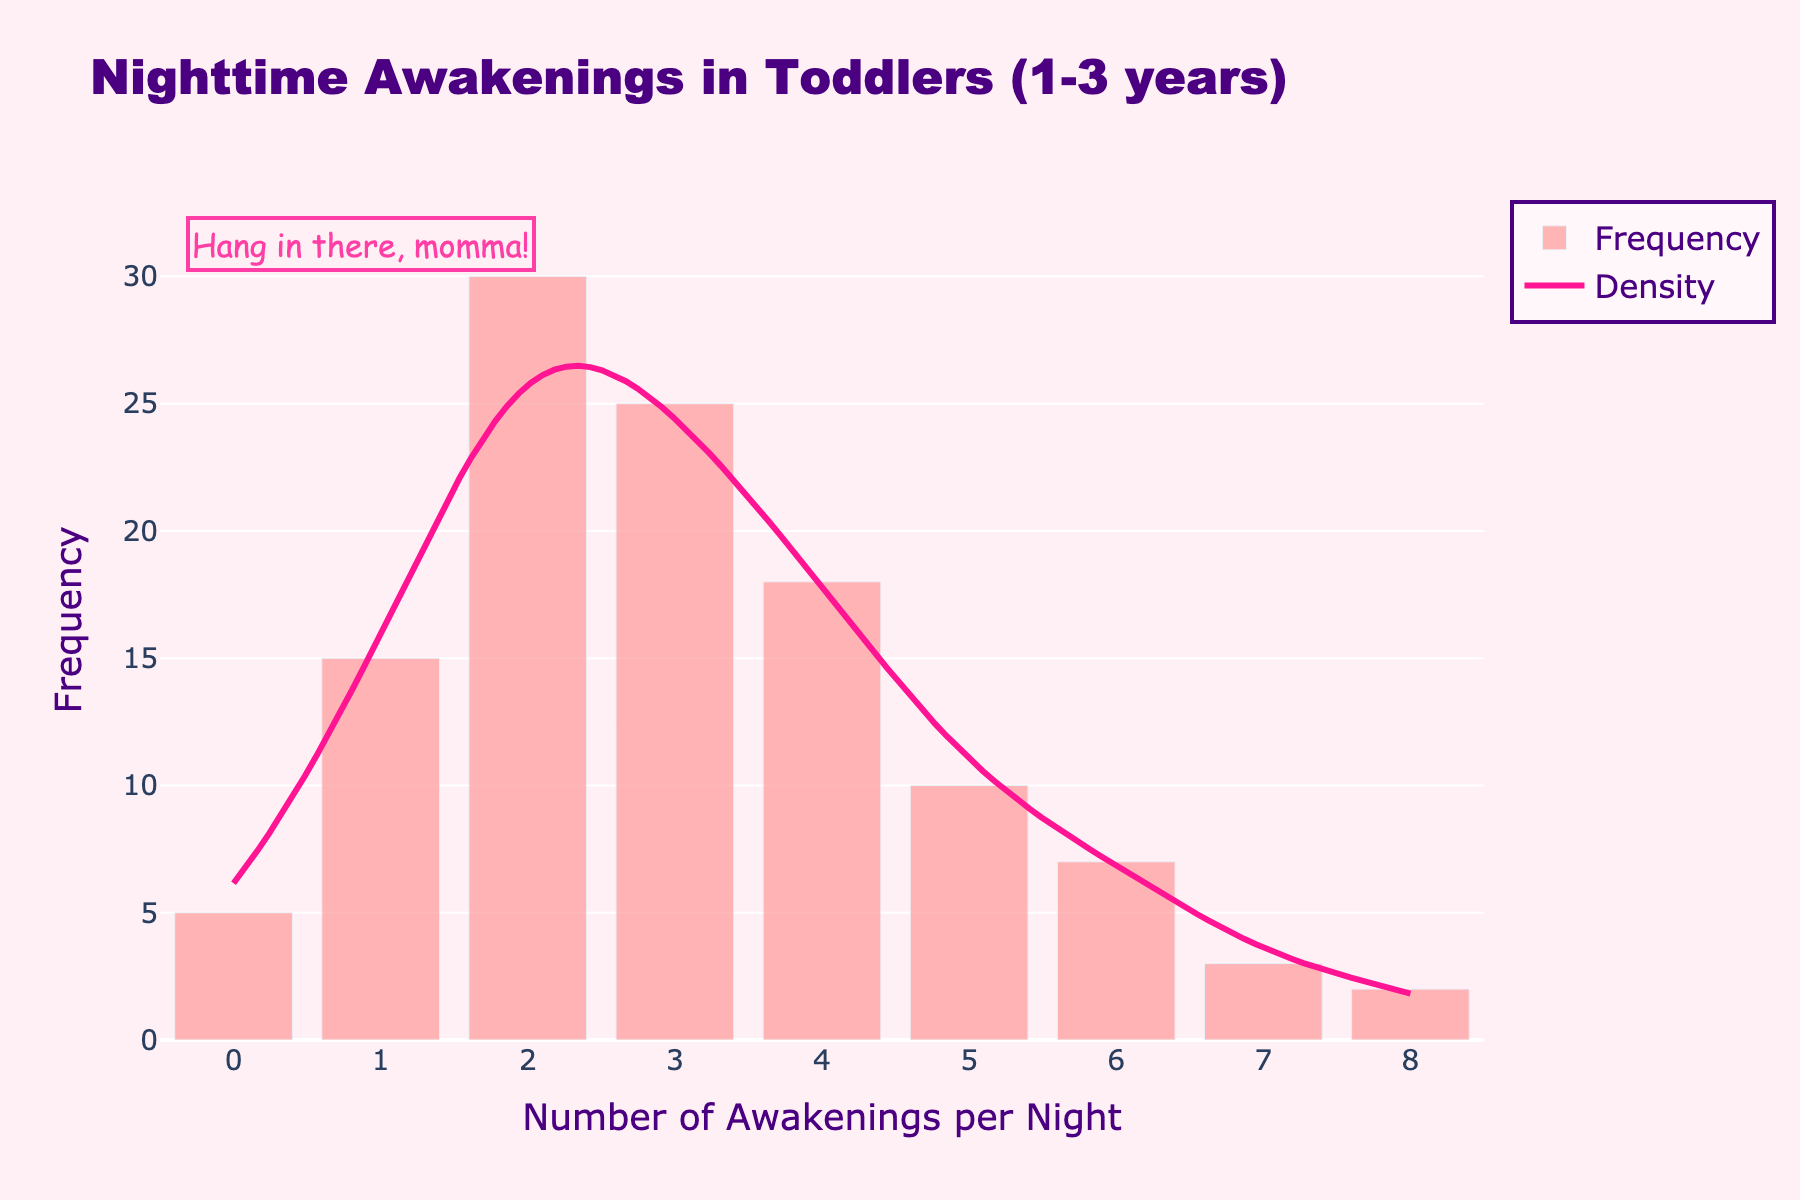how many awakenings per night are recorded most frequently? The highest bar in the histogram represents the frequency of awakenings per night. The bar for "2 awakenings per night" is the tallest, with a frequency of 30.
Answer: 2 awakenings what is the title of the figure? The title of the figure is displayed at the top center in a large font. It reads "Nighttime Awakenings in Toddlers (1-3 years)".
Answer: Nighttime Awakenings in Toddlers (1-3 years) which number of awakenings per night has the lowest frequency? By looking at the height of the bars in the histogram, the bar labelled "8 awakenings per night" is the shortest with a frequency of 2.
Answer: 8 awakenings what is the range of the x-axis? The x-axis is labelled "Number of Awakenings per Night" and its range is from -0.5 to 8.5.
Answer: -0.5 to 8.5 which has a higher frequency, 3 awakenings per night or 5? Comparing the heights of the bars labelled "3 awakenings per night" and "5 awakenings per night," the bar for 3 has a frequency of 25, while the bar for 5 has a frequency of 10. Therefore, 3 awakenings per night has a higher frequency.
Answer: 3 awakenings how many toddlers wake up 4 times per night? The frequency for toddlers waking up 4 times per night is represented by the bar labelled "4 awakenings per night," which has a frequency of 18.
Answer: 18 toddlers are there more toddlers waking up 0 times or 7 times per night? By comparing the heights of the bars labelled "0 awakenings per night" and "7 awakenings per night," the bar for 0 awakenings has a frequency of 5, and the bar for 7 awakenings has a frequency of 3. Therefore, more toddlers wake up 0 times per night.
Answer: 0 awakenings how does the frequency of toddlers waking up 1 time per night compare to those waking up 6 times per night? The frequency for "1 awakening per night" is shown as 15, while the frequency for "6 awakenings per night" is shown as 7. Therefore, more toddlers wake up 1 time per night compared to 6 times per night.
Answer: 1 times what is the purpose of the pink line curve? The pink line curve overlaid on the histogram represents the KDE (density curve) which shows the estimated probability density function of nighttime awakenings. It smooths the distribution, indicating how the frequencies are spread out.
Answer: KDE (density curve) how many toddlers wake up 2 or 3 times per night? To find this, add the frequency of toddlers waking up 2 times per night and 3 times per night. The frequency for 2 awakenings is 30 and for 3 awakenings is 25. Therefore, the total is 30 + 25 = 55.
Answer: 55 toddlers 